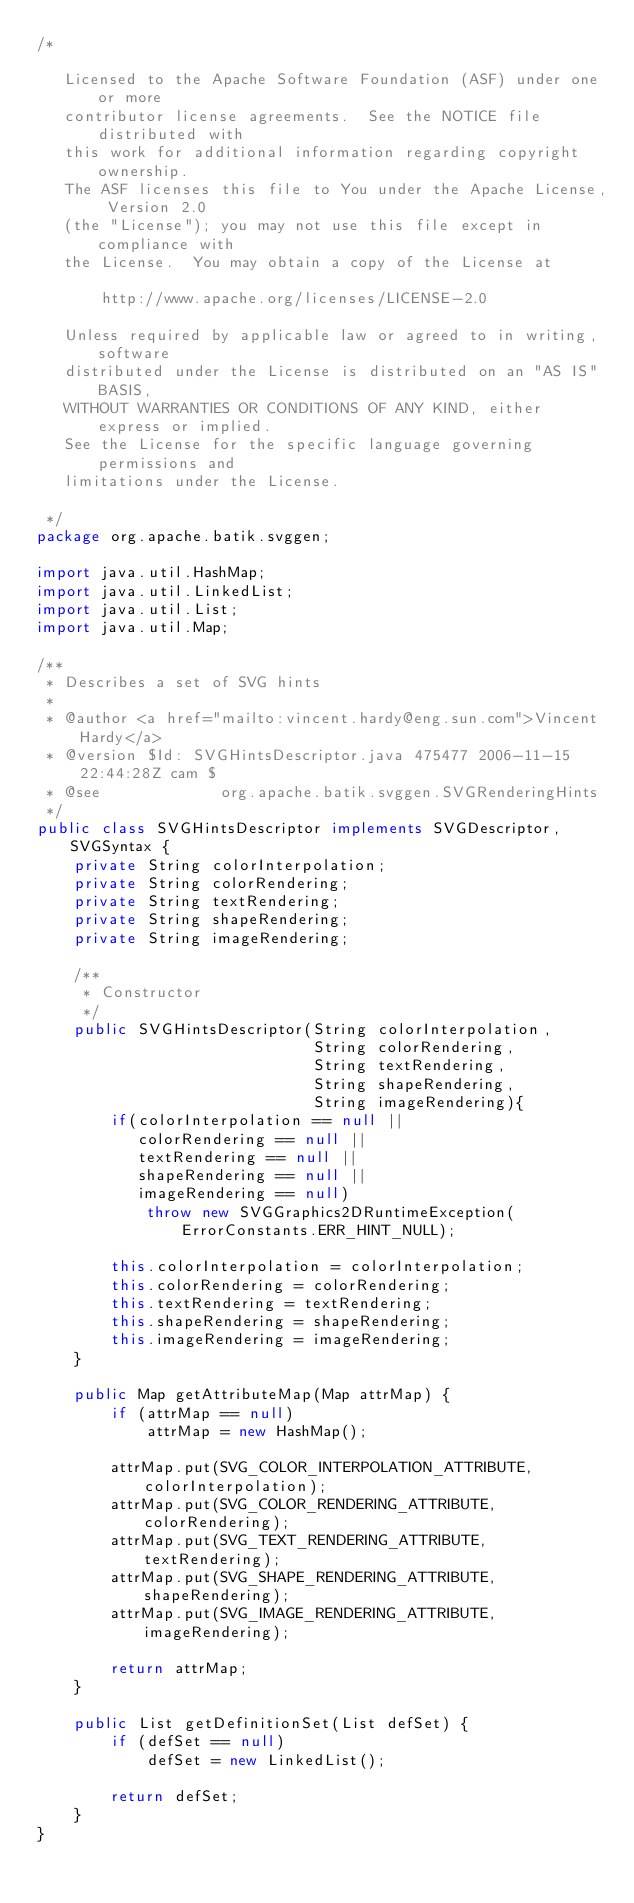Convert code to text. <code><loc_0><loc_0><loc_500><loc_500><_Java_>/*

   Licensed to the Apache Software Foundation (ASF) under one or more
   contributor license agreements.  See the NOTICE file distributed with
   this work for additional information regarding copyright ownership.
   The ASF licenses this file to You under the Apache License, Version 2.0
   (the "License"); you may not use this file except in compliance with
   the License.  You may obtain a copy of the License at

       http://www.apache.org/licenses/LICENSE-2.0

   Unless required by applicable law or agreed to in writing, software
   distributed under the License is distributed on an "AS IS" BASIS,
   WITHOUT WARRANTIES OR CONDITIONS OF ANY KIND, either express or implied.
   See the License for the specific language governing permissions and
   limitations under the License.

 */
package org.apache.batik.svggen;

import java.util.HashMap;
import java.util.LinkedList;
import java.util.List;
import java.util.Map;

/**
 * Describes a set of SVG hints
 *
 * @author <a href="mailto:vincent.hardy@eng.sun.com">Vincent Hardy</a>
 * @version $Id: SVGHintsDescriptor.java 475477 2006-11-15 22:44:28Z cam $
 * @see             org.apache.batik.svggen.SVGRenderingHints
 */
public class SVGHintsDescriptor implements SVGDescriptor, SVGSyntax {
    private String colorInterpolation;
    private String colorRendering;
    private String textRendering;
    private String shapeRendering;
    private String imageRendering;

    /**
     * Constructor
     */
    public SVGHintsDescriptor(String colorInterpolation,
                              String colorRendering,
                              String textRendering,
                              String shapeRendering,
                              String imageRendering){
        if(colorInterpolation == null ||
           colorRendering == null ||
           textRendering == null ||
           shapeRendering == null ||
           imageRendering == null)
            throw new SVGGraphics2DRuntimeException(ErrorConstants.ERR_HINT_NULL);

        this.colorInterpolation = colorInterpolation;
        this.colorRendering = colorRendering;
        this.textRendering = textRendering;
        this.shapeRendering = shapeRendering;
        this.imageRendering = imageRendering;
    }

    public Map getAttributeMap(Map attrMap) {
        if (attrMap == null)
            attrMap = new HashMap();

        attrMap.put(SVG_COLOR_INTERPOLATION_ATTRIBUTE, colorInterpolation);
        attrMap.put(SVG_COLOR_RENDERING_ATTRIBUTE, colorRendering);
        attrMap.put(SVG_TEXT_RENDERING_ATTRIBUTE, textRendering);
        attrMap.put(SVG_SHAPE_RENDERING_ATTRIBUTE, shapeRendering);
        attrMap.put(SVG_IMAGE_RENDERING_ATTRIBUTE, imageRendering);

        return attrMap;
    }

    public List getDefinitionSet(List defSet) {
        if (defSet == null)
            defSet = new LinkedList();

        return defSet;
    }
}
</code> 